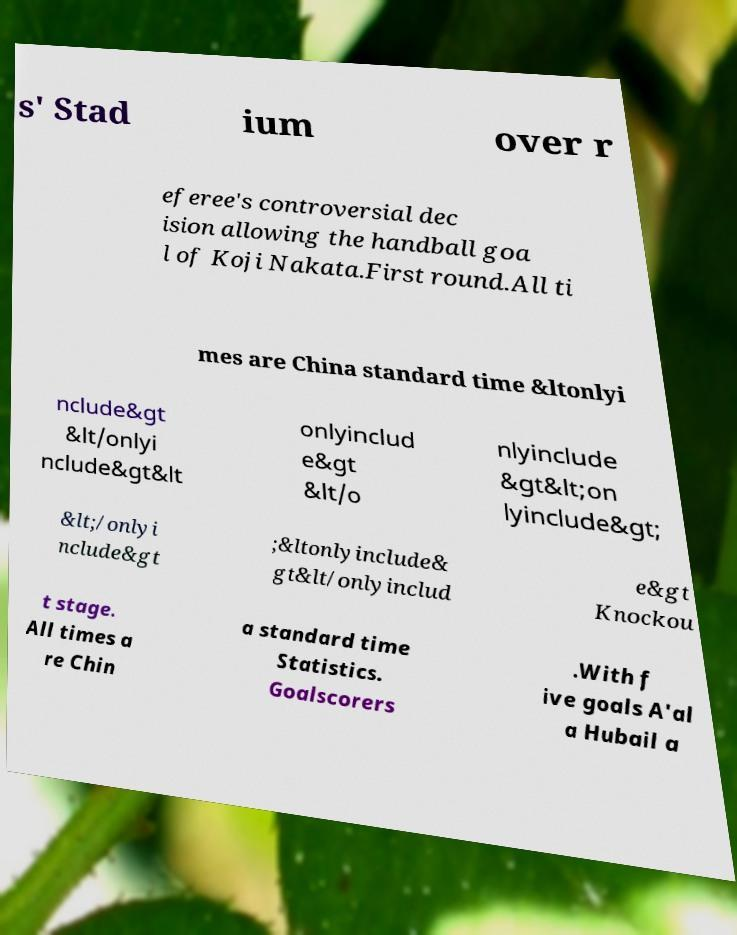Can you read and provide the text displayed in the image?This photo seems to have some interesting text. Can you extract and type it out for me? s' Stad ium over r eferee's controversial dec ision allowing the handball goa l of Koji Nakata.First round.All ti mes are China standard time &ltonlyi nclude&gt &lt/onlyi nclude&gt&lt onlyinclud e&gt &lt/o nlyinclude &gt&lt;on lyinclude&gt; &lt;/onlyi nclude&gt ;&ltonlyinclude& gt&lt/onlyinclud e&gt Knockou t stage. All times a re Chin a standard time Statistics. Goalscorers .With f ive goals A'al a Hubail a 